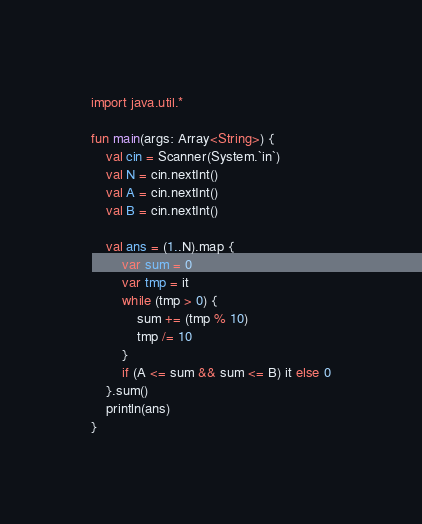<code> <loc_0><loc_0><loc_500><loc_500><_Kotlin_>import java.util.*

fun main(args: Array<String>) {
    val cin = Scanner(System.`in`)
    val N = cin.nextInt()
    val A = cin.nextInt()
    val B = cin.nextInt()

    val ans = (1..N).map {
        var sum = 0
        var tmp = it
        while (tmp > 0) {
            sum += (tmp % 10)
            tmp /= 10
        }
        if (A <= sum && sum <= B) it else 0
    }.sum()
    println(ans)
}</code> 